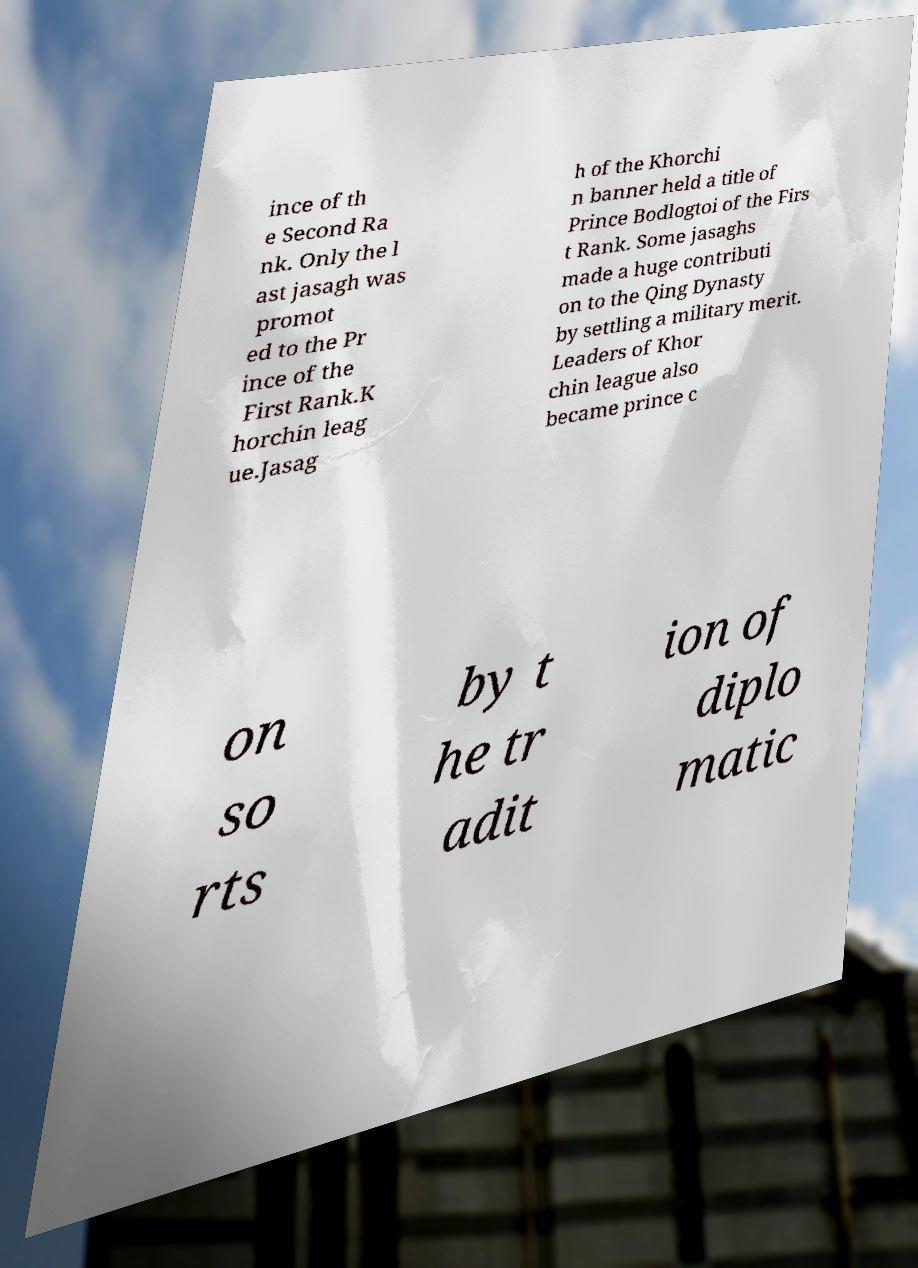Please identify and transcribe the text found in this image. ince of th e Second Ra nk. Only the l ast jasagh was promot ed to the Pr ince of the First Rank.K horchin leag ue.Jasag h of the Khorchi n banner held a title of Prince Bodlogtoi of the Firs t Rank. Some jasaghs made a huge contributi on to the Qing Dynasty by settling a military merit. Leaders of Khor chin league also became prince c on so rts by t he tr adit ion of diplo matic 